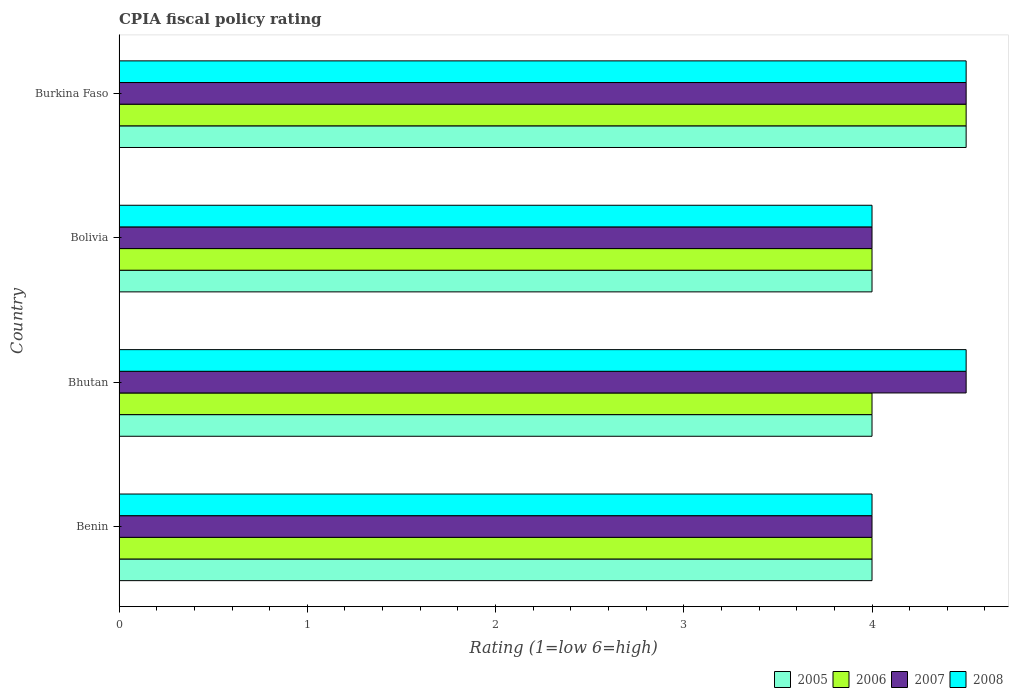How many different coloured bars are there?
Keep it short and to the point. 4. How many groups of bars are there?
Provide a short and direct response. 4. How many bars are there on the 1st tick from the top?
Give a very brief answer. 4. How many bars are there on the 3rd tick from the bottom?
Make the answer very short. 4. What is the label of the 3rd group of bars from the top?
Give a very brief answer. Bhutan. Across all countries, what is the maximum CPIA rating in 2007?
Your answer should be very brief. 4.5. Across all countries, what is the minimum CPIA rating in 2006?
Offer a very short reply. 4. In which country was the CPIA rating in 2005 maximum?
Give a very brief answer. Burkina Faso. In which country was the CPIA rating in 2008 minimum?
Provide a short and direct response. Benin. What is the difference between the CPIA rating in 2006 in Burkina Faso and the CPIA rating in 2007 in Benin?
Your response must be concise. 0.5. What is the average CPIA rating in 2005 per country?
Keep it short and to the point. 4.12. What is the difference between the CPIA rating in 2006 and CPIA rating in 2008 in Bolivia?
Give a very brief answer. 0. In how many countries, is the CPIA rating in 2008 greater than 2.8 ?
Offer a terse response. 4. Is the CPIA rating in 2005 in Benin less than that in Bolivia?
Ensure brevity in your answer.  No. Is the difference between the CPIA rating in 2006 in Bhutan and Bolivia greater than the difference between the CPIA rating in 2008 in Bhutan and Bolivia?
Provide a short and direct response. No. What is the difference between the highest and the second highest CPIA rating in 2008?
Offer a very short reply. 0. What does the 4th bar from the top in Benin represents?
Your response must be concise. 2005. What does the 1st bar from the bottom in Bolivia represents?
Make the answer very short. 2005. Is it the case that in every country, the sum of the CPIA rating in 2005 and CPIA rating in 2007 is greater than the CPIA rating in 2008?
Make the answer very short. Yes. Are all the bars in the graph horizontal?
Ensure brevity in your answer.  Yes. How many countries are there in the graph?
Your answer should be compact. 4. What is the difference between two consecutive major ticks on the X-axis?
Your response must be concise. 1. Does the graph contain any zero values?
Provide a short and direct response. No. Where does the legend appear in the graph?
Your answer should be compact. Bottom right. What is the title of the graph?
Your response must be concise. CPIA fiscal policy rating. Does "2005" appear as one of the legend labels in the graph?
Provide a short and direct response. Yes. What is the label or title of the X-axis?
Offer a very short reply. Rating (1=low 6=high). What is the Rating (1=low 6=high) of 2007 in Benin?
Your response must be concise. 4. What is the Rating (1=low 6=high) of 2008 in Benin?
Keep it short and to the point. 4. What is the Rating (1=low 6=high) of 2005 in Bhutan?
Provide a succinct answer. 4. What is the Rating (1=low 6=high) in 2008 in Bhutan?
Your answer should be very brief. 4.5. What is the Rating (1=low 6=high) in 2006 in Bolivia?
Offer a very short reply. 4. What is the Rating (1=low 6=high) in 2007 in Bolivia?
Ensure brevity in your answer.  4. What is the Rating (1=low 6=high) of 2008 in Bolivia?
Provide a succinct answer. 4. What is the Rating (1=low 6=high) in 2005 in Burkina Faso?
Offer a terse response. 4.5. What is the Rating (1=low 6=high) of 2006 in Burkina Faso?
Offer a very short reply. 4.5. Across all countries, what is the maximum Rating (1=low 6=high) of 2005?
Your answer should be compact. 4.5. Across all countries, what is the minimum Rating (1=low 6=high) of 2005?
Keep it short and to the point. 4. What is the total Rating (1=low 6=high) in 2005 in the graph?
Your answer should be very brief. 16.5. What is the total Rating (1=low 6=high) in 2006 in the graph?
Your answer should be very brief. 16.5. What is the total Rating (1=low 6=high) in 2007 in the graph?
Ensure brevity in your answer.  17. What is the difference between the Rating (1=low 6=high) of 2005 in Benin and that in Bhutan?
Provide a short and direct response. 0. What is the difference between the Rating (1=low 6=high) in 2006 in Benin and that in Bhutan?
Your answer should be compact. 0. What is the difference between the Rating (1=low 6=high) in 2007 in Benin and that in Bhutan?
Your answer should be compact. -0.5. What is the difference between the Rating (1=low 6=high) of 2008 in Benin and that in Bhutan?
Provide a succinct answer. -0.5. What is the difference between the Rating (1=low 6=high) of 2005 in Benin and that in Bolivia?
Your answer should be compact. 0. What is the difference between the Rating (1=low 6=high) of 2006 in Benin and that in Bolivia?
Ensure brevity in your answer.  0. What is the difference between the Rating (1=low 6=high) of 2007 in Benin and that in Bolivia?
Your response must be concise. 0. What is the difference between the Rating (1=low 6=high) of 2005 in Benin and that in Burkina Faso?
Provide a short and direct response. -0.5. What is the difference between the Rating (1=low 6=high) in 2008 in Benin and that in Burkina Faso?
Offer a terse response. -0.5. What is the difference between the Rating (1=low 6=high) in 2006 in Bhutan and that in Bolivia?
Your response must be concise. 0. What is the difference between the Rating (1=low 6=high) of 2008 in Bhutan and that in Bolivia?
Keep it short and to the point. 0.5. What is the difference between the Rating (1=low 6=high) of 2005 in Bhutan and that in Burkina Faso?
Ensure brevity in your answer.  -0.5. What is the difference between the Rating (1=low 6=high) in 2006 in Bhutan and that in Burkina Faso?
Keep it short and to the point. -0.5. What is the difference between the Rating (1=low 6=high) in 2005 in Bolivia and that in Burkina Faso?
Keep it short and to the point. -0.5. What is the difference between the Rating (1=low 6=high) in 2007 in Bolivia and that in Burkina Faso?
Provide a short and direct response. -0.5. What is the difference between the Rating (1=low 6=high) of 2005 in Benin and the Rating (1=low 6=high) of 2007 in Bhutan?
Your answer should be very brief. -0.5. What is the difference between the Rating (1=low 6=high) of 2006 in Benin and the Rating (1=low 6=high) of 2008 in Bhutan?
Offer a very short reply. -0.5. What is the difference between the Rating (1=low 6=high) of 2005 in Benin and the Rating (1=low 6=high) of 2007 in Bolivia?
Your response must be concise. 0. What is the difference between the Rating (1=low 6=high) of 2006 in Benin and the Rating (1=low 6=high) of 2007 in Bolivia?
Provide a succinct answer. 0. What is the difference between the Rating (1=low 6=high) of 2005 in Benin and the Rating (1=low 6=high) of 2007 in Burkina Faso?
Ensure brevity in your answer.  -0.5. What is the difference between the Rating (1=low 6=high) in 2005 in Benin and the Rating (1=low 6=high) in 2008 in Burkina Faso?
Your answer should be very brief. -0.5. What is the difference between the Rating (1=low 6=high) of 2006 in Benin and the Rating (1=low 6=high) of 2008 in Burkina Faso?
Offer a very short reply. -0.5. What is the difference between the Rating (1=low 6=high) of 2005 in Bhutan and the Rating (1=low 6=high) of 2008 in Bolivia?
Provide a succinct answer. 0. What is the difference between the Rating (1=low 6=high) of 2006 in Bhutan and the Rating (1=low 6=high) of 2007 in Bolivia?
Offer a very short reply. 0. What is the difference between the Rating (1=low 6=high) of 2006 in Bhutan and the Rating (1=low 6=high) of 2008 in Bolivia?
Give a very brief answer. 0. What is the difference between the Rating (1=low 6=high) in 2007 in Bhutan and the Rating (1=low 6=high) in 2008 in Bolivia?
Make the answer very short. 0.5. What is the difference between the Rating (1=low 6=high) of 2005 in Bhutan and the Rating (1=low 6=high) of 2006 in Burkina Faso?
Ensure brevity in your answer.  -0.5. What is the difference between the Rating (1=low 6=high) in 2005 in Bhutan and the Rating (1=low 6=high) in 2007 in Burkina Faso?
Your answer should be compact. -0.5. What is the difference between the Rating (1=low 6=high) of 2006 in Bhutan and the Rating (1=low 6=high) of 2008 in Burkina Faso?
Make the answer very short. -0.5. What is the difference between the Rating (1=low 6=high) of 2005 in Bolivia and the Rating (1=low 6=high) of 2006 in Burkina Faso?
Provide a succinct answer. -0.5. What is the difference between the Rating (1=low 6=high) of 2006 in Bolivia and the Rating (1=low 6=high) of 2008 in Burkina Faso?
Ensure brevity in your answer.  -0.5. What is the average Rating (1=low 6=high) in 2005 per country?
Make the answer very short. 4.12. What is the average Rating (1=low 6=high) in 2006 per country?
Offer a very short reply. 4.12. What is the average Rating (1=low 6=high) in 2007 per country?
Offer a terse response. 4.25. What is the average Rating (1=low 6=high) of 2008 per country?
Your answer should be compact. 4.25. What is the difference between the Rating (1=low 6=high) in 2005 and Rating (1=low 6=high) in 2006 in Benin?
Provide a succinct answer. 0. What is the difference between the Rating (1=low 6=high) of 2005 and Rating (1=low 6=high) of 2007 in Benin?
Your answer should be very brief. 0. What is the difference between the Rating (1=low 6=high) in 2005 and Rating (1=low 6=high) in 2008 in Benin?
Keep it short and to the point. 0. What is the difference between the Rating (1=low 6=high) in 2007 and Rating (1=low 6=high) in 2008 in Benin?
Offer a terse response. 0. What is the difference between the Rating (1=low 6=high) of 2005 and Rating (1=low 6=high) of 2007 in Bhutan?
Give a very brief answer. -0.5. What is the difference between the Rating (1=low 6=high) in 2005 and Rating (1=low 6=high) in 2008 in Bhutan?
Keep it short and to the point. -0.5. What is the difference between the Rating (1=low 6=high) in 2006 and Rating (1=low 6=high) in 2007 in Bhutan?
Give a very brief answer. -0.5. What is the difference between the Rating (1=low 6=high) of 2007 and Rating (1=low 6=high) of 2008 in Bhutan?
Provide a succinct answer. 0. What is the difference between the Rating (1=low 6=high) in 2005 and Rating (1=low 6=high) in 2006 in Bolivia?
Your answer should be compact. 0. What is the difference between the Rating (1=low 6=high) of 2005 and Rating (1=low 6=high) of 2007 in Bolivia?
Offer a very short reply. 0. What is the difference between the Rating (1=low 6=high) of 2006 and Rating (1=low 6=high) of 2008 in Bolivia?
Offer a terse response. 0. What is the difference between the Rating (1=low 6=high) in 2007 and Rating (1=low 6=high) in 2008 in Bolivia?
Offer a very short reply. 0. What is the difference between the Rating (1=low 6=high) of 2005 and Rating (1=low 6=high) of 2008 in Burkina Faso?
Ensure brevity in your answer.  0. What is the difference between the Rating (1=low 6=high) in 2006 and Rating (1=low 6=high) in 2007 in Burkina Faso?
Offer a very short reply. 0. What is the difference between the Rating (1=low 6=high) in 2006 and Rating (1=low 6=high) in 2008 in Burkina Faso?
Provide a short and direct response. 0. What is the ratio of the Rating (1=low 6=high) in 2005 in Benin to that in Bhutan?
Provide a succinct answer. 1. What is the ratio of the Rating (1=low 6=high) of 2006 in Benin to that in Bhutan?
Give a very brief answer. 1. What is the ratio of the Rating (1=low 6=high) in 2008 in Benin to that in Bhutan?
Offer a terse response. 0.89. What is the ratio of the Rating (1=low 6=high) of 2008 in Benin to that in Bolivia?
Make the answer very short. 1. What is the ratio of the Rating (1=low 6=high) in 2006 in Benin to that in Burkina Faso?
Make the answer very short. 0.89. What is the ratio of the Rating (1=low 6=high) in 2007 in Benin to that in Burkina Faso?
Keep it short and to the point. 0.89. What is the ratio of the Rating (1=low 6=high) in 2005 in Bhutan to that in Bolivia?
Provide a succinct answer. 1. What is the ratio of the Rating (1=low 6=high) in 2008 in Bhutan to that in Bolivia?
Provide a succinct answer. 1.12. What is the ratio of the Rating (1=low 6=high) of 2007 in Bhutan to that in Burkina Faso?
Ensure brevity in your answer.  1. What is the ratio of the Rating (1=low 6=high) of 2005 in Bolivia to that in Burkina Faso?
Offer a very short reply. 0.89. What is the difference between the highest and the second highest Rating (1=low 6=high) in 2005?
Offer a very short reply. 0.5. What is the difference between the highest and the second highest Rating (1=low 6=high) in 2007?
Provide a succinct answer. 0. What is the difference between the highest and the second highest Rating (1=low 6=high) of 2008?
Your response must be concise. 0. 